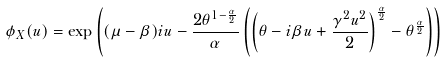<formula> <loc_0><loc_0><loc_500><loc_500>\phi _ { X } ( u ) & = \exp \left ( ( \mu - \beta ) i u - \frac { 2 \theta ^ { 1 - \frac { \alpha } { 2 } } } { \alpha } \left ( \left ( \theta - i \beta u + \frac { \gamma ^ { 2 } u ^ { 2 } } { 2 } \right ) ^ { \frac { \alpha } { 2 } } - \theta ^ { \frac { \alpha } { 2 } } \right ) \right )</formula> 